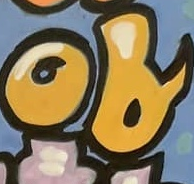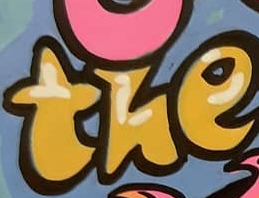What words are shown in these images in order, separated by a semicolon? of; the 